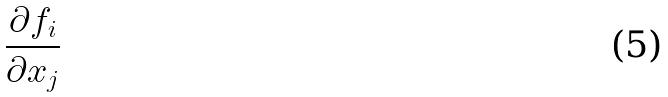Convert formula to latex. <formula><loc_0><loc_0><loc_500><loc_500>\frac { \partial f _ { i } } { \partial x _ { j } }</formula> 